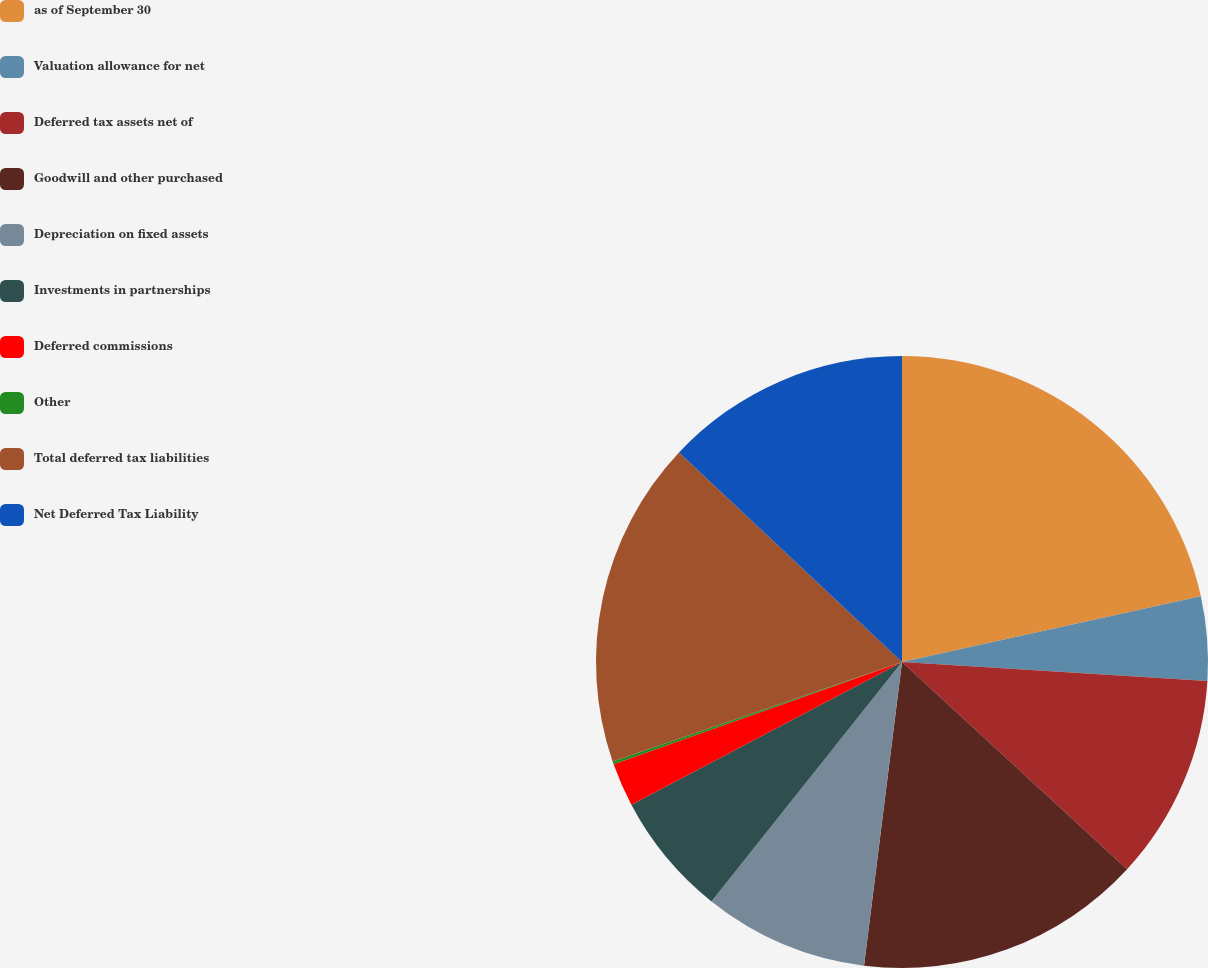<chart> <loc_0><loc_0><loc_500><loc_500><pie_chart><fcel>as of September 30<fcel>Valuation allowance for net<fcel>Deferred tax assets net of<fcel>Goodwill and other purchased<fcel>Depreciation on fixed assets<fcel>Investments in partnerships<fcel>Deferred commissions<fcel>Other<fcel>Total deferred tax liabilities<fcel>Net Deferred Tax Liability<nl><fcel>21.56%<fcel>4.44%<fcel>10.86%<fcel>15.14%<fcel>8.72%<fcel>6.58%<fcel>2.3%<fcel>0.16%<fcel>17.28%<fcel>13.0%<nl></chart> 